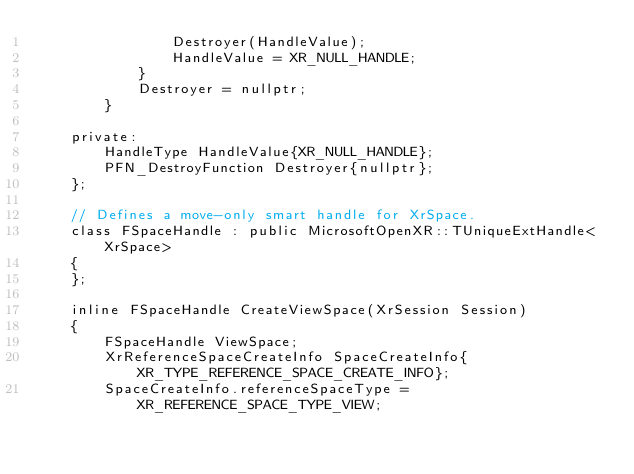<code> <loc_0><loc_0><loc_500><loc_500><_C_>				Destroyer(HandleValue);
				HandleValue = XR_NULL_HANDLE;
			}
			Destroyer = nullptr;
		}

	private:
		HandleType HandleValue{XR_NULL_HANDLE};
		PFN_DestroyFunction Destroyer{nullptr};
	};

	// Defines a move-only smart handle for XrSpace.
	class FSpaceHandle : public MicrosoftOpenXR::TUniqueExtHandle<XrSpace>
	{
	};

	inline FSpaceHandle CreateViewSpace(XrSession Session)
	{
		FSpaceHandle ViewSpace;
		XrReferenceSpaceCreateInfo SpaceCreateInfo{XR_TYPE_REFERENCE_SPACE_CREATE_INFO};
		SpaceCreateInfo.referenceSpaceType = XR_REFERENCE_SPACE_TYPE_VIEW;</code> 